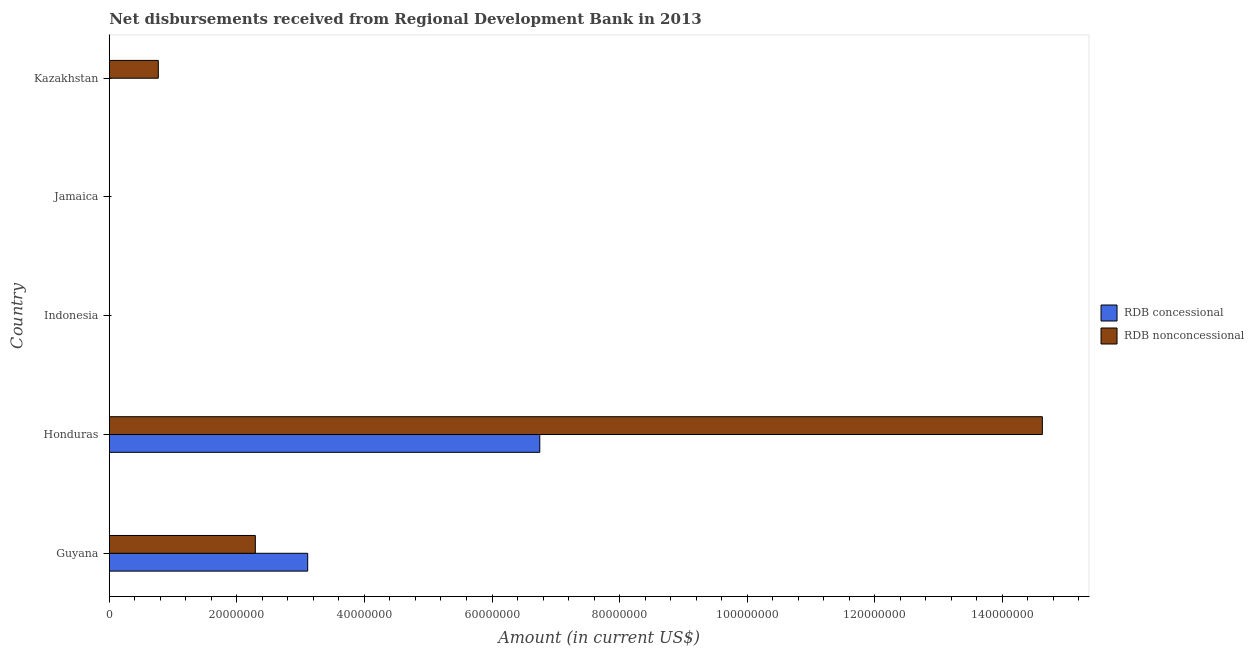What is the label of the 1st group of bars from the top?
Give a very brief answer. Kazakhstan. Across all countries, what is the maximum net non concessional disbursements from rdb?
Your answer should be very brief. 1.46e+08. In which country was the net concessional disbursements from rdb maximum?
Your answer should be compact. Honduras. What is the total net concessional disbursements from rdb in the graph?
Offer a very short reply. 9.86e+07. What is the difference between the net non concessional disbursements from rdb in Guyana and that in Honduras?
Make the answer very short. -1.23e+08. What is the difference between the net concessional disbursements from rdb in Guyana and the net non concessional disbursements from rdb in Jamaica?
Offer a very short reply. 3.11e+07. What is the average net concessional disbursements from rdb per country?
Offer a terse response. 1.97e+07. What is the difference between the net concessional disbursements from rdb and net non concessional disbursements from rdb in Guyana?
Offer a terse response. 8.21e+06. In how many countries, is the net concessional disbursements from rdb greater than 48000000 US$?
Your answer should be compact. 1. What is the difference between the highest and the second highest net non concessional disbursements from rdb?
Your response must be concise. 1.23e+08. What is the difference between the highest and the lowest net concessional disbursements from rdb?
Provide a short and direct response. 6.75e+07. What is the difference between two consecutive major ticks on the X-axis?
Your answer should be compact. 2.00e+07. Are the values on the major ticks of X-axis written in scientific E-notation?
Your answer should be very brief. No. Does the graph contain grids?
Your answer should be compact. No. What is the title of the graph?
Keep it short and to the point. Net disbursements received from Regional Development Bank in 2013. Does "Underweight" appear as one of the legend labels in the graph?
Give a very brief answer. No. What is the Amount (in current US$) of RDB concessional in Guyana?
Offer a very short reply. 3.11e+07. What is the Amount (in current US$) of RDB nonconcessional in Guyana?
Provide a succinct answer. 2.29e+07. What is the Amount (in current US$) in RDB concessional in Honduras?
Offer a very short reply. 6.75e+07. What is the Amount (in current US$) in RDB nonconcessional in Honduras?
Ensure brevity in your answer.  1.46e+08. What is the Amount (in current US$) of RDB concessional in Jamaica?
Your answer should be very brief. 0. What is the Amount (in current US$) of RDB nonconcessional in Jamaica?
Your response must be concise. 0. What is the Amount (in current US$) in RDB nonconcessional in Kazakhstan?
Provide a succinct answer. 7.69e+06. Across all countries, what is the maximum Amount (in current US$) in RDB concessional?
Ensure brevity in your answer.  6.75e+07. Across all countries, what is the maximum Amount (in current US$) in RDB nonconcessional?
Keep it short and to the point. 1.46e+08. Across all countries, what is the minimum Amount (in current US$) of RDB nonconcessional?
Your response must be concise. 0. What is the total Amount (in current US$) of RDB concessional in the graph?
Offer a very short reply. 9.86e+07. What is the total Amount (in current US$) of RDB nonconcessional in the graph?
Your response must be concise. 1.77e+08. What is the difference between the Amount (in current US$) of RDB concessional in Guyana and that in Honduras?
Your response must be concise. -3.64e+07. What is the difference between the Amount (in current US$) of RDB nonconcessional in Guyana and that in Honduras?
Make the answer very short. -1.23e+08. What is the difference between the Amount (in current US$) of RDB nonconcessional in Guyana and that in Kazakhstan?
Your response must be concise. 1.52e+07. What is the difference between the Amount (in current US$) of RDB nonconcessional in Honduras and that in Kazakhstan?
Give a very brief answer. 1.39e+08. What is the difference between the Amount (in current US$) of RDB concessional in Guyana and the Amount (in current US$) of RDB nonconcessional in Honduras?
Keep it short and to the point. -1.15e+08. What is the difference between the Amount (in current US$) of RDB concessional in Guyana and the Amount (in current US$) of RDB nonconcessional in Kazakhstan?
Provide a short and direct response. 2.34e+07. What is the difference between the Amount (in current US$) in RDB concessional in Honduras and the Amount (in current US$) in RDB nonconcessional in Kazakhstan?
Provide a short and direct response. 5.98e+07. What is the average Amount (in current US$) in RDB concessional per country?
Your answer should be very brief. 1.97e+07. What is the average Amount (in current US$) in RDB nonconcessional per country?
Provide a succinct answer. 3.54e+07. What is the difference between the Amount (in current US$) of RDB concessional and Amount (in current US$) of RDB nonconcessional in Guyana?
Your answer should be compact. 8.21e+06. What is the difference between the Amount (in current US$) in RDB concessional and Amount (in current US$) in RDB nonconcessional in Honduras?
Keep it short and to the point. -7.88e+07. What is the ratio of the Amount (in current US$) of RDB concessional in Guyana to that in Honduras?
Your response must be concise. 0.46. What is the ratio of the Amount (in current US$) in RDB nonconcessional in Guyana to that in Honduras?
Offer a terse response. 0.16. What is the ratio of the Amount (in current US$) in RDB nonconcessional in Guyana to that in Kazakhstan?
Give a very brief answer. 2.98. What is the ratio of the Amount (in current US$) of RDB nonconcessional in Honduras to that in Kazakhstan?
Provide a succinct answer. 19.03. What is the difference between the highest and the second highest Amount (in current US$) of RDB nonconcessional?
Ensure brevity in your answer.  1.23e+08. What is the difference between the highest and the lowest Amount (in current US$) of RDB concessional?
Give a very brief answer. 6.75e+07. What is the difference between the highest and the lowest Amount (in current US$) in RDB nonconcessional?
Keep it short and to the point. 1.46e+08. 